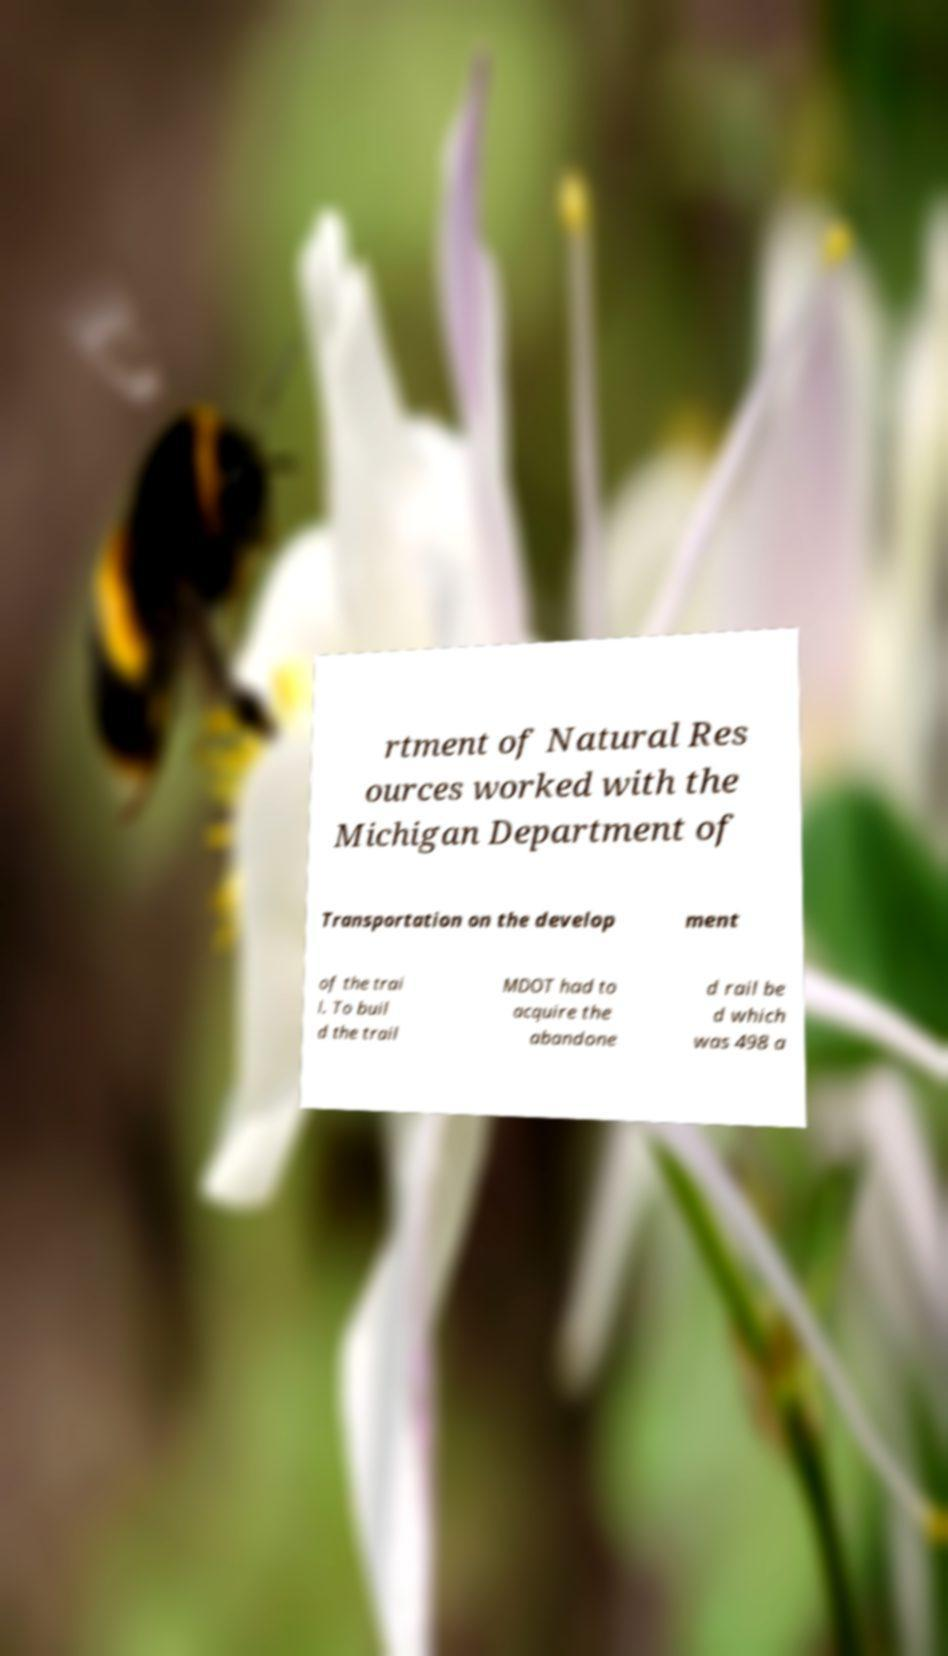Can you read and provide the text displayed in the image?This photo seems to have some interesting text. Can you extract and type it out for me? rtment of Natural Res ources worked with the Michigan Department of Transportation on the develop ment of the trai l. To buil d the trail MDOT had to acquire the abandone d rail be d which was 498 a 